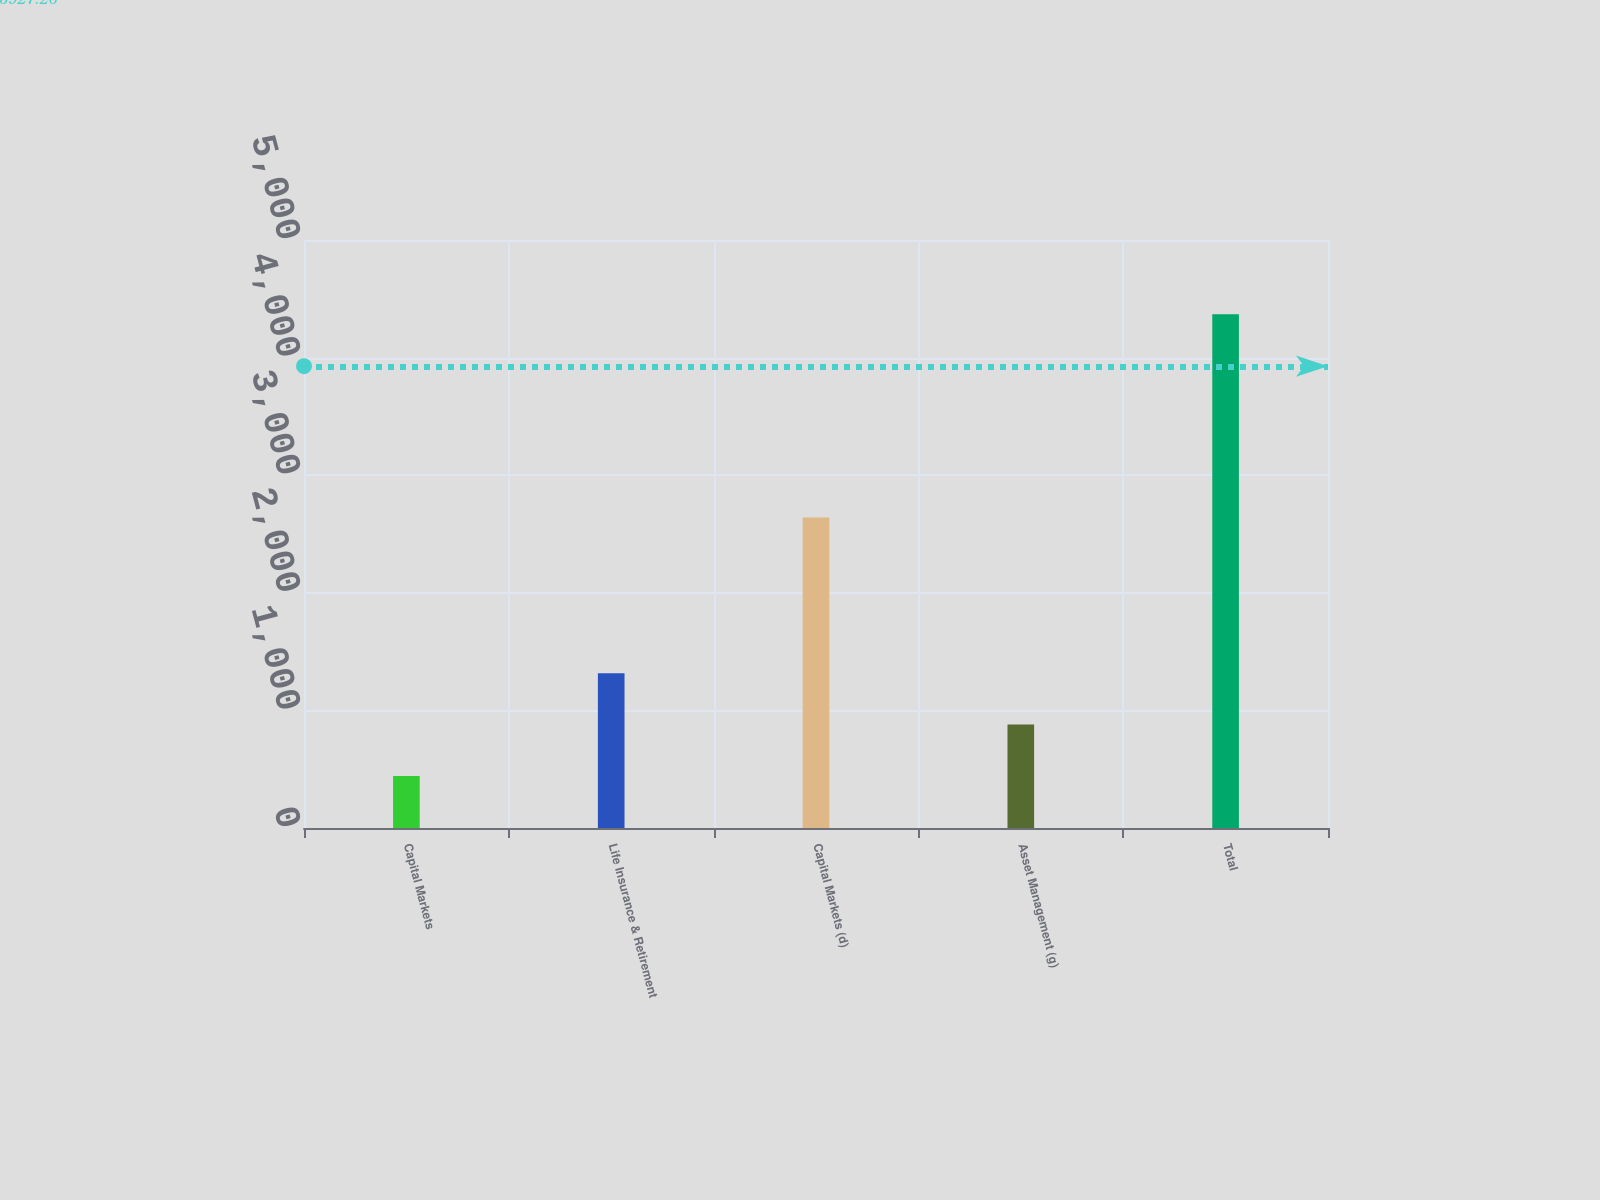<chart> <loc_0><loc_0><loc_500><loc_500><bar_chart><fcel>Capital Markets<fcel>Life Insurance & Retirement<fcel>Capital Markets (d)<fcel>Asset Management (g)<fcel>Total<nl><fcel>443.1<fcel>1315.3<fcel>2640<fcel>879.2<fcel>4368<nl></chart> 